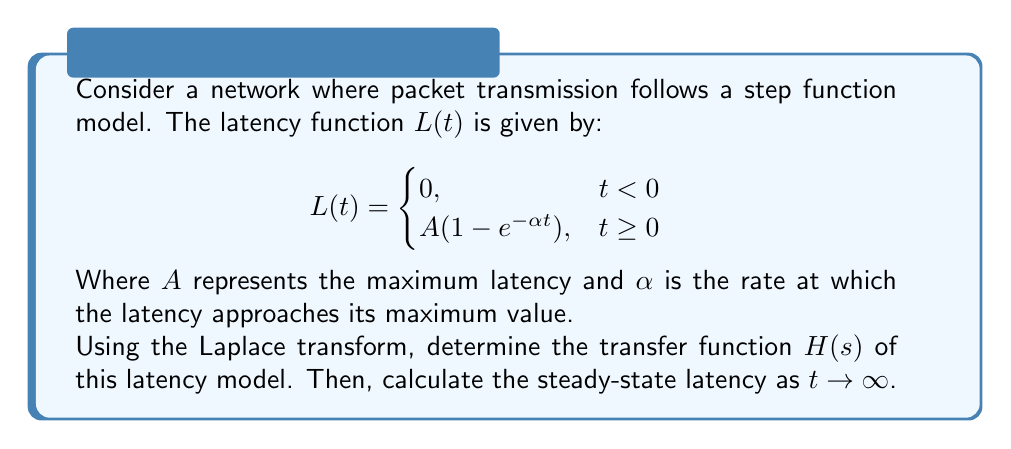Give your solution to this math problem. 1) First, we need to find the Laplace transform of $L(t)$. The Laplace transform of a step function multiplied by $(1 - e^{-\alpha t})$ is given by:

   $$\mathcal{L}\{L(t)\} = A \cdot \frac{1}{s} - A \cdot \frac{1}{s+\alpha}$$

2) Simplify this expression:

   $$\mathcal{L}\{L(t)\} = A \cdot \frac{s+\alpha - s}{s(s+\alpha)} = A \cdot \frac{\alpha}{s(s+\alpha)}$$

3) The transfer function $H(s)$ is defined as the Laplace transform of the output divided by the Laplace transform of the input. In this case, the input is a unit step function with Laplace transform $1/s$. Therefore:

   $$H(s) = \frac{\mathcal{L}\{L(t)\}}{\mathcal{L}\{u(t)\}} = \frac{A \cdot \frac{\alpha}{s(s+\alpha)}}{1/s} = \frac{A\alpha}{s+\alpha}$$

4) To find the steady-state latency as $t \to \infty$, we can use the Final Value Theorem:

   $$\lim_{t \to \infty} L(t) = \lim_{s \to 0} sH(s) = \lim_{s \to 0} s \cdot \frac{A\alpha}{s+\alpha} = A$$

Therefore, the steady-state latency is $A$, which matches our intuition from the original function.
Answer: $H(s) = \frac{A\alpha}{s+\alpha}$; Steady-state latency = $A$ 